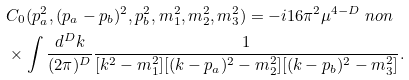<formula> <loc_0><loc_0><loc_500><loc_500>& C _ { 0 } ( p _ { a } ^ { 2 } , ( p _ { a } - p _ { b } ) ^ { 2 } , p _ { b } ^ { 2 } , m _ { 1 } ^ { 2 } , m _ { 2 } ^ { 2 } , m _ { 3 } ^ { 2 } ) = - i 1 6 \pi ^ { 2 } \mu ^ { 4 - D } \ n o n \\ & \times \int \frac { d ^ { D } k } { ( 2 \pi ) ^ { D } } \frac { 1 } { [ k ^ { 2 } - m _ { 1 } ^ { 2 } ] [ ( k - p _ { a } ) ^ { 2 } - m _ { 2 } ^ { 2 } ] [ ( k - p _ { b } ) ^ { 2 } - m _ { 3 } ^ { 2 } ] } .</formula> 